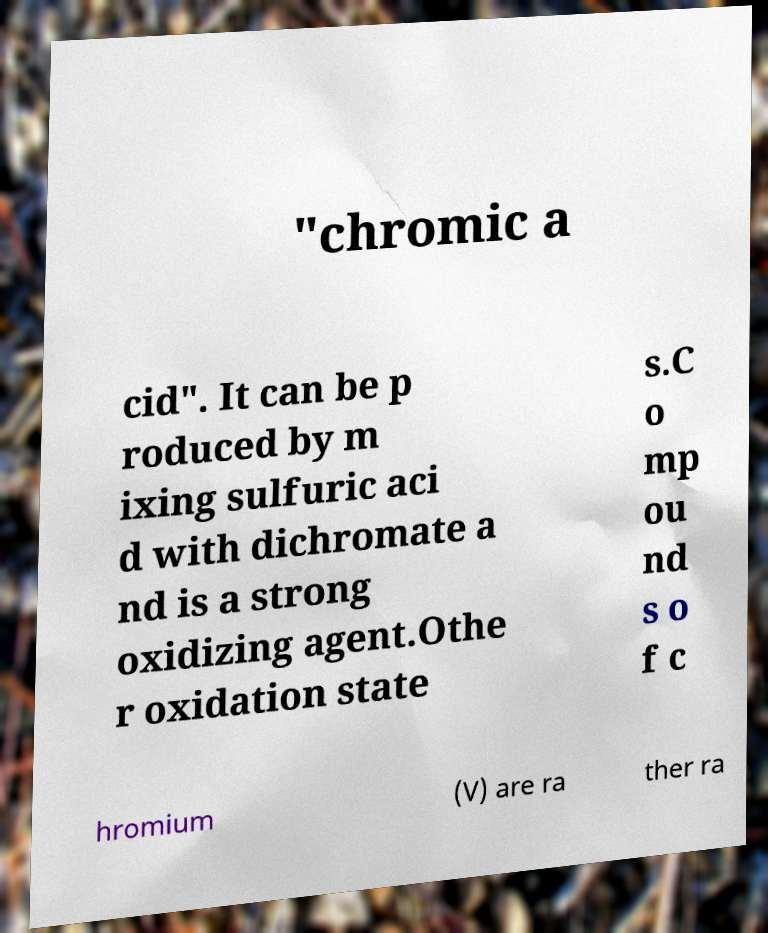Could you extract and type out the text from this image? "chromic a cid". It can be p roduced by m ixing sulfuric aci d with dichromate a nd is a strong oxidizing agent.Othe r oxidation state s.C o mp ou nd s o f c hromium (V) are ra ther ra 